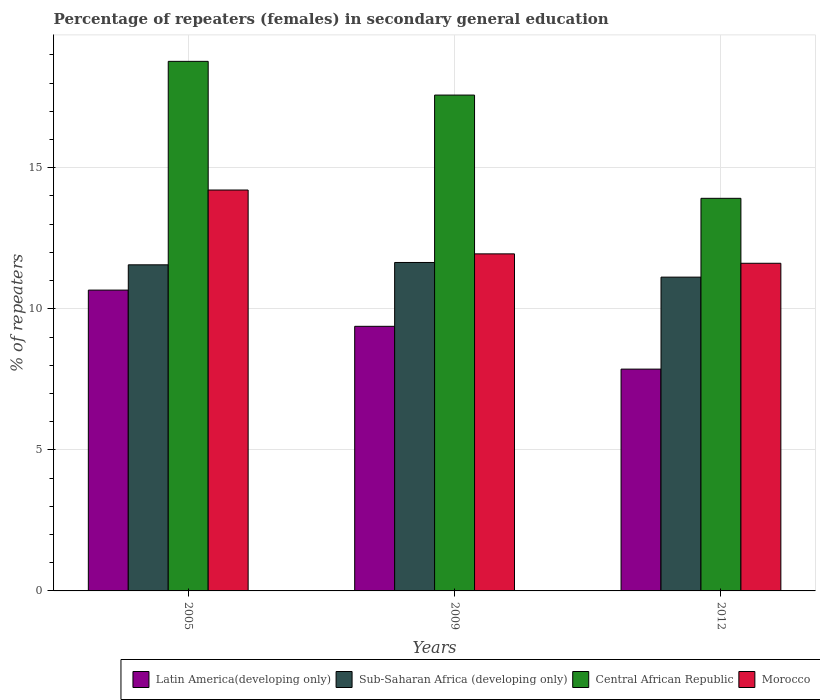Are the number of bars per tick equal to the number of legend labels?
Give a very brief answer. Yes. Are the number of bars on each tick of the X-axis equal?
Your answer should be very brief. Yes. How many bars are there on the 2nd tick from the left?
Offer a very short reply. 4. How many bars are there on the 2nd tick from the right?
Provide a succinct answer. 4. In how many cases, is the number of bars for a given year not equal to the number of legend labels?
Provide a succinct answer. 0. What is the percentage of female repeaters in Morocco in 2005?
Your response must be concise. 14.21. Across all years, what is the maximum percentage of female repeaters in Morocco?
Ensure brevity in your answer.  14.21. Across all years, what is the minimum percentage of female repeaters in Latin America(developing only)?
Your answer should be very brief. 7.86. In which year was the percentage of female repeaters in Central African Republic minimum?
Make the answer very short. 2012. What is the total percentage of female repeaters in Latin America(developing only) in the graph?
Make the answer very short. 27.91. What is the difference between the percentage of female repeaters in Sub-Saharan Africa (developing only) in 2009 and that in 2012?
Give a very brief answer. 0.52. What is the difference between the percentage of female repeaters in Morocco in 2009 and the percentage of female repeaters in Latin America(developing only) in 2012?
Your response must be concise. 4.09. What is the average percentage of female repeaters in Central African Republic per year?
Your answer should be compact. 16.76. In the year 2009, what is the difference between the percentage of female repeaters in Sub-Saharan Africa (developing only) and percentage of female repeaters in Morocco?
Give a very brief answer. -0.31. What is the ratio of the percentage of female repeaters in Central African Republic in 2005 to that in 2012?
Keep it short and to the point. 1.35. Is the percentage of female repeaters in Sub-Saharan Africa (developing only) in 2005 less than that in 2012?
Your response must be concise. No. What is the difference between the highest and the second highest percentage of female repeaters in Latin America(developing only)?
Offer a very short reply. 1.28. What is the difference between the highest and the lowest percentage of female repeaters in Latin America(developing only)?
Offer a very short reply. 2.8. In how many years, is the percentage of female repeaters in Latin America(developing only) greater than the average percentage of female repeaters in Latin America(developing only) taken over all years?
Your response must be concise. 2. Is the sum of the percentage of female repeaters in Central African Republic in 2009 and 2012 greater than the maximum percentage of female repeaters in Morocco across all years?
Your answer should be compact. Yes. What does the 2nd bar from the left in 2012 represents?
Keep it short and to the point. Sub-Saharan Africa (developing only). What does the 2nd bar from the right in 2005 represents?
Ensure brevity in your answer.  Central African Republic. What is the difference between two consecutive major ticks on the Y-axis?
Ensure brevity in your answer.  5. Does the graph contain grids?
Provide a short and direct response. Yes. Where does the legend appear in the graph?
Your response must be concise. Bottom right. How many legend labels are there?
Provide a succinct answer. 4. How are the legend labels stacked?
Your answer should be compact. Horizontal. What is the title of the graph?
Provide a succinct answer. Percentage of repeaters (females) in secondary general education. Does "Sub-Saharan Africa (all income levels)" appear as one of the legend labels in the graph?
Offer a terse response. No. What is the label or title of the Y-axis?
Make the answer very short. % of repeaters. What is the % of repeaters in Latin America(developing only) in 2005?
Ensure brevity in your answer.  10.66. What is the % of repeaters in Sub-Saharan Africa (developing only) in 2005?
Give a very brief answer. 11.56. What is the % of repeaters of Central African Republic in 2005?
Ensure brevity in your answer.  18.77. What is the % of repeaters of Morocco in 2005?
Provide a short and direct response. 14.21. What is the % of repeaters of Latin America(developing only) in 2009?
Offer a terse response. 9.38. What is the % of repeaters in Sub-Saharan Africa (developing only) in 2009?
Give a very brief answer. 11.64. What is the % of repeaters in Central African Republic in 2009?
Make the answer very short. 17.58. What is the % of repeaters of Morocco in 2009?
Your answer should be very brief. 11.95. What is the % of repeaters in Latin America(developing only) in 2012?
Ensure brevity in your answer.  7.86. What is the % of repeaters in Sub-Saharan Africa (developing only) in 2012?
Provide a succinct answer. 11.12. What is the % of repeaters in Central African Republic in 2012?
Give a very brief answer. 13.92. What is the % of repeaters in Morocco in 2012?
Your answer should be compact. 11.61. Across all years, what is the maximum % of repeaters in Latin America(developing only)?
Keep it short and to the point. 10.66. Across all years, what is the maximum % of repeaters of Sub-Saharan Africa (developing only)?
Keep it short and to the point. 11.64. Across all years, what is the maximum % of repeaters in Central African Republic?
Keep it short and to the point. 18.77. Across all years, what is the maximum % of repeaters in Morocco?
Your response must be concise. 14.21. Across all years, what is the minimum % of repeaters of Latin America(developing only)?
Provide a succinct answer. 7.86. Across all years, what is the minimum % of repeaters of Sub-Saharan Africa (developing only)?
Offer a terse response. 11.12. Across all years, what is the minimum % of repeaters in Central African Republic?
Your answer should be very brief. 13.92. Across all years, what is the minimum % of repeaters in Morocco?
Provide a short and direct response. 11.61. What is the total % of repeaters of Latin America(developing only) in the graph?
Make the answer very short. 27.91. What is the total % of repeaters of Sub-Saharan Africa (developing only) in the graph?
Provide a short and direct response. 34.32. What is the total % of repeaters of Central African Republic in the graph?
Make the answer very short. 50.27. What is the total % of repeaters in Morocco in the graph?
Make the answer very short. 37.77. What is the difference between the % of repeaters of Latin America(developing only) in 2005 and that in 2009?
Your answer should be compact. 1.28. What is the difference between the % of repeaters of Sub-Saharan Africa (developing only) in 2005 and that in 2009?
Ensure brevity in your answer.  -0.08. What is the difference between the % of repeaters of Central African Republic in 2005 and that in 2009?
Your answer should be compact. 1.2. What is the difference between the % of repeaters of Morocco in 2005 and that in 2009?
Provide a succinct answer. 2.26. What is the difference between the % of repeaters of Latin America(developing only) in 2005 and that in 2012?
Ensure brevity in your answer.  2.8. What is the difference between the % of repeaters of Sub-Saharan Africa (developing only) in 2005 and that in 2012?
Offer a terse response. 0.44. What is the difference between the % of repeaters of Central African Republic in 2005 and that in 2012?
Offer a very short reply. 4.86. What is the difference between the % of repeaters in Morocco in 2005 and that in 2012?
Provide a succinct answer. 2.6. What is the difference between the % of repeaters of Latin America(developing only) in 2009 and that in 2012?
Your answer should be very brief. 1.52. What is the difference between the % of repeaters of Sub-Saharan Africa (developing only) in 2009 and that in 2012?
Provide a succinct answer. 0.52. What is the difference between the % of repeaters in Central African Republic in 2009 and that in 2012?
Ensure brevity in your answer.  3.66. What is the difference between the % of repeaters of Morocco in 2009 and that in 2012?
Your answer should be very brief. 0.33. What is the difference between the % of repeaters of Latin America(developing only) in 2005 and the % of repeaters of Sub-Saharan Africa (developing only) in 2009?
Offer a very short reply. -0.98. What is the difference between the % of repeaters in Latin America(developing only) in 2005 and the % of repeaters in Central African Republic in 2009?
Offer a very short reply. -6.91. What is the difference between the % of repeaters of Latin America(developing only) in 2005 and the % of repeaters of Morocco in 2009?
Offer a very short reply. -1.28. What is the difference between the % of repeaters of Sub-Saharan Africa (developing only) in 2005 and the % of repeaters of Central African Republic in 2009?
Your answer should be very brief. -6.02. What is the difference between the % of repeaters of Sub-Saharan Africa (developing only) in 2005 and the % of repeaters of Morocco in 2009?
Keep it short and to the point. -0.39. What is the difference between the % of repeaters of Central African Republic in 2005 and the % of repeaters of Morocco in 2009?
Give a very brief answer. 6.82. What is the difference between the % of repeaters in Latin America(developing only) in 2005 and the % of repeaters in Sub-Saharan Africa (developing only) in 2012?
Keep it short and to the point. -0.46. What is the difference between the % of repeaters in Latin America(developing only) in 2005 and the % of repeaters in Central African Republic in 2012?
Offer a terse response. -3.25. What is the difference between the % of repeaters in Latin America(developing only) in 2005 and the % of repeaters in Morocco in 2012?
Give a very brief answer. -0.95. What is the difference between the % of repeaters in Sub-Saharan Africa (developing only) in 2005 and the % of repeaters in Central African Republic in 2012?
Offer a very short reply. -2.36. What is the difference between the % of repeaters in Sub-Saharan Africa (developing only) in 2005 and the % of repeaters in Morocco in 2012?
Give a very brief answer. -0.05. What is the difference between the % of repeaters in Central African Republic in 2005 and the % of repeaters in Morocco in 2012?
Your answer should be very brief. 7.16. What is the difference between the % of repeaters in Latin America(developing only) in 2009 and the % of repeaters in Sub-Saharan Africa (developing only) in 2012?
Your answer should be very brief. -1.74. What is the difference between the % of repeaters in Latin America(developing only) in 2009 and the % of repeaters in Central African Republic in 2012?
Make the answer very short. -4.54. What is the difference between the % of repeaters of Latin America(developing only) in 2009 and the % of repeaters of Morocco in 2012?
Your answer should be compact. -2.23. What is the difference between the % of repeaters in Sub-Saharan Africa (developing only) in 2009 and the % of repeaters in Central African Republic in 2012?
Offer a very short reply. -2.27. What is the difference between the % of repeaters of Sub-Saharan Africa (developing only) in 2009 and the % of repeaters of Morocco in 2012?
Ensure brevity in your answer.  0.03. What is the difference between the % of repeaters in Central African Republic in 2009 and the % of repeaters in Morocco in 2012?
Offer a very short reply. 5.96. What is the average % of repeaters in Latin America(developing only) per year?
Offer a terse response. 9.3. What is the average % of repeaters in Sub-Saharan Africa (developing only) per year?
Ensure brevity in your answer.  11.44. What is the average % of repeaters in Central African Republic per year?
Your answer should be compact. 16.76. What is the average % of repeaters in Morocco per year?
Ensure brevity in your answer.  12.59. In the year 2005, what is the difference between the % of repeaters of Latin America(developing only) and % of repeaters of Sub-Saharan Africa (developing only)?
Ensure brevity in your answer.  -0.9. In the year 2005, what is the difference between the % of repeaters in Latin America(developing only) and % of repeaters in Central African Republic?
Keep it short and to the point. -8.11. In the year 2005, what is the difference between the % of repeaters of Latin America(developing only) and % of repeaters of Morocco?
Ensure brevity in your answer.  -3.55. In the year 2005, what is the difference between the % of repeaters of Sub-Saharan Africa (developing only) and % of repeaters of Central African Republic?
Offer a terse response. -7.21. In the year 2005, what is the difference between the % of repeaters in Sub-Saharan Africa (developing only) and % of repeaters in Morocco?
Keep it short and to the point. -2.65. In the year 2005, what is the difference between the % of repeaters in Central African Republic and % of repeaters in Morocco?
Your answer should be very brief. 4.56. In the year 2009, what is the difference between the % of repeaters of Latin America(developing only) and % of repeaters of Sub-Saharan Africa (developing only)?
Offer a terse response. -2.26. In the year 2009, what is the difference between the % of repeaters of Latin America(developing only) and % of repeaters of Central African Republic?
Make the answer very short. -8.2. In the year 2009, what is the difference between the % of repeaters of Latin America(developing only) and % of repeaters of Morocco?
Provide a short and direct response. -2.57. In the year 2009, what is the difference between the % of repeaters in Sub-Saharan Africa (developing only) and % of repeaters in Central African Republic?
Give a very brief answer. -5.93. In the year 2009, what is the difference between the % of repeaters of Sub-Saharan Africa (developing only) and % of repeaters of Morocco?
Give a very brief answer. -0.31. In the year 2009, what is the difference between the % of repeaters of Central African Republic and % of repeaters of Morocco?
Provide a succinct answer. 5.63. In the year 2012, what is the difference between the % of repeaters in Latin America(developing only) and % of repeaters in Sub-Saharan Africa (developing only)?
Give a very brief answer. -3.26. In the year 2012, what is the difference between the % of repeaters of Latin America(developing only) and % of repeaters of Central African Republic?
Give a very brief answer. -6.05. In the year 2012, what is the difference between the % of repeaters of Latin America(developing only) and % of repeaters of Morocco?
Make the answer very short. -3.75. In the year 2012, what is the difference between the % of repeaters of Sub-Saharan Africa (developing only) and % of repeaters of Central African Republic?
Offer a very short reply. -2.79. In the year 2012, what is the difference between the % of repeaters in Sub-Saharan Africa (developing only) and % of repeaters in Morocco?
Give a very brief answer. -0.49. In the year 2012, what is the difference between the % of repeaters of Central African Republic and % of repeaters of Morocco?
Give a very brief answer. 2.3. What is the ratio of the % of repeaters of Latin America(developing only) in 2005 to that in 2009?
Give a very brief answer. 1.14. What is the ratio of the % of repeaters in Sub-Saharan Africa (developing only) in 2005 to that in 2009?
Ensure brevity in your answer.  0.99. What is the ratio of the % of repeaters in Central African Republic in 2005 to that in 2009?
Ensure brevity in your answer.  1.07. What is the ratio of the % of repeaters in Morocco in 2005 to that in 2009?
Give a very brief answer. 1.19. What is the ratio of the % of repeaters in Latin America(developing only) in 2005 to that in 2012?
Your answer should be compact. 1.36. What is the ratio of the % of repeaters in Sub-Saharan Africa (developing only) in 2005 to that in 2012?
Your response must be concise. 1.04. What is the ratio of the % of repeaters in Central African Republic in 2005 to that in 2012?
Your response must be concise. 1.35. What is the ratio of the % of repeaters in Morocco in 2005 to that in 2012?
Keep it short and to the point. 1.22. What is the ratio of the % of repeaters in Latin America(developing only) in 2009 to that in 2012?
Offer a very short reply. 1.19. What is the ratio of the % of repeaters in Sub-Saharan Africa (developing only) in 2009 to that in 2012?
Offer a terse response. 1.05. What is the ratio of the % of repeaters of Central African Republic in 2009 to that in 2012?
Offer a very short reply. 1.26. What is the ratio of the % of repeaters in Morocco in 2009 to that in 2012?
Your answer should be very brief. 1.03. What is the difference between the highest and the second highest % of repeaters in Latin America(developing only)?
Ensure brevity in your answer.  1.28. What is the difference between the highest and the second highest % of repeaters of Sub-Saharan Africa (developing only)?
Keep it short and to the point. 0.08. What is the difference between the highest and the second highest % of repeaters in Central African Republic?
Offer a terse response. 1.2. What is the difference between the highest and the second highest % of repeaters in Morocco?
Make the answer very short. 2.26. What is the difference between the highest and the lowest % of repeaters of Latin America(developing only)?
Offer a very short reply. 2.8. What is the difference between the highest and the lowest % of repeaters of Sub-Saharan Africa (developing only)?
Provide a succinct answer. 0.52. What is the difference between the highest and the lowest % of repeaters in Central African Republic?
Provide a short and direct response. 4.86. What is the difference between the highest and the lowest % of repeaters of Morocco?
Your response must be concise. 2.6. 